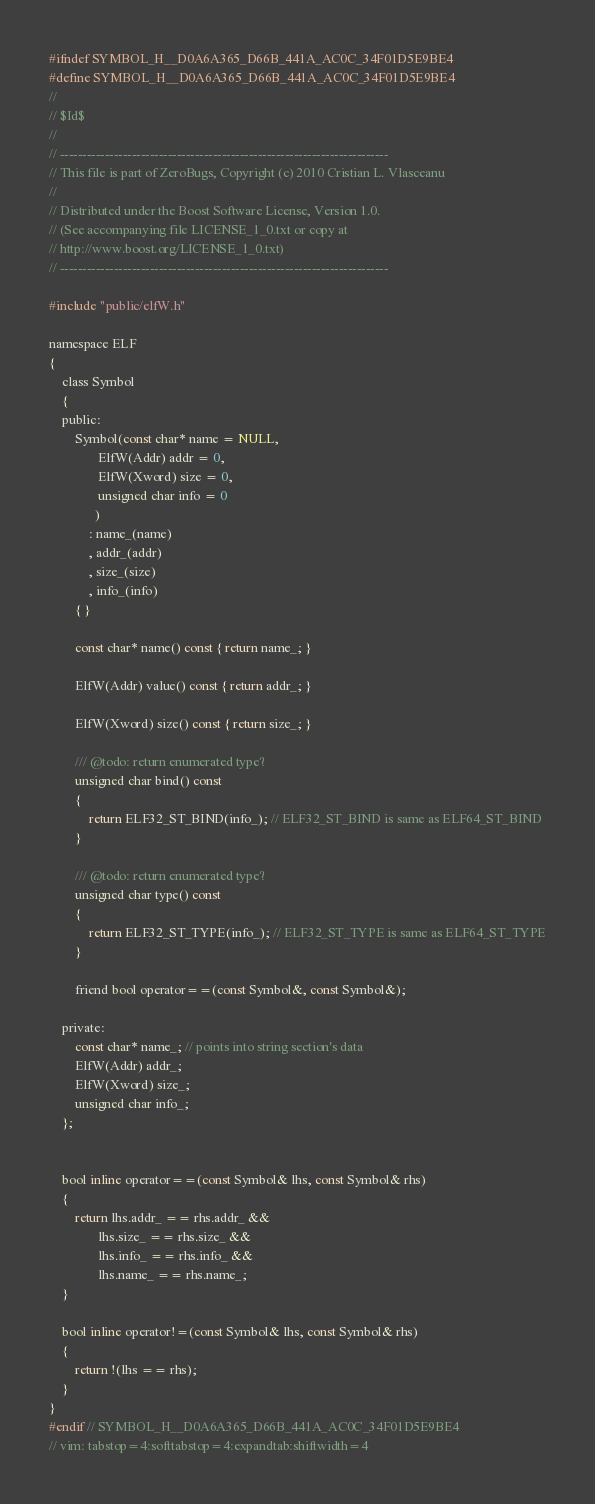<code> <loc_0><loc_0><loc_500><loc_500><_C_>#ifndef SYMBOL_H__D0A6A365_D66B_441A_AC0C_34F01D5E9BE4
#define SYMBOL_H__D0A6A365_D66B_441A_AC0C_34F01D5E9BE4
//
// $Id$
//
// -------------------------------------------------------------------------
// This file is part of ZeroBugs, Copyright (c) 2010 Cristian L. Vlasceanu
//
// Distributed under the Boost Software License, Version 1.0.
// (See accompanying file LICENSE_1_0.txt or copy at
// http://www.boost.org/LICENSE_1_0.txt)
// -------------------------------------------------------------------------

#include "public/elfW.h"

namespace ELF
{
    class Symbol
    {
    public:
        Symbol(const char* name = NULL,
               ElfW(Addr) addr = 0,
               ElfW(Xword) size = 0,
               unsigned char info = 0
              )
            : name_(name)
            , addr_(addr)
            , size_(size)
            , info_(info)
        { }

        const char* name() const { return name_; }

        ElfW(Addr) value() const { return addr_; }

        ElfW(Xword) size() const { return size_; }

        /// @todo: return enumerated type?
        unsigned char bind() const
        {
            return ELF32_ST_BIND(info_); // ELF32_ST_BIND is same as ELF64_ST_BIND
        }

        /// @todo: return enumerated type?
        unsigned char type() const
        {
            return ELF32_ST_TYPE(info_); // ELF32_ST_TYPE is same as ELF64_ST_TYPE
        }

        friend bool operator==(const Symbol&, const Symbol&);

    private:
        const char* name_; // points into string section's data
        ElfW(Addr) addr_;
        ElfW(Xword) size_;
        unsigned char info_;
    };


    bool inline operator==(const Symbol& lhs, const Symbol& rhs)
    {
        return lhs.addr_ == rhs.addr_ &&
               lhs.size_ == rhs.size_ &&
               lhs.info_ == rhs.info_ &&
               lhs.name_ == rhs.name_;
    }

    bool inline operator!=(const Symbol& lhs, const Symbol& rhs)
    {
        return !(lhs == rhs);
    }
}
#endif // SYMBOL_H__D0A6A365_D66B_441A_AC0C_34F01D5E9BE4
// vim: tabstop=4:softtabstop=4:expandtab:shiftwidth=4
</code> 